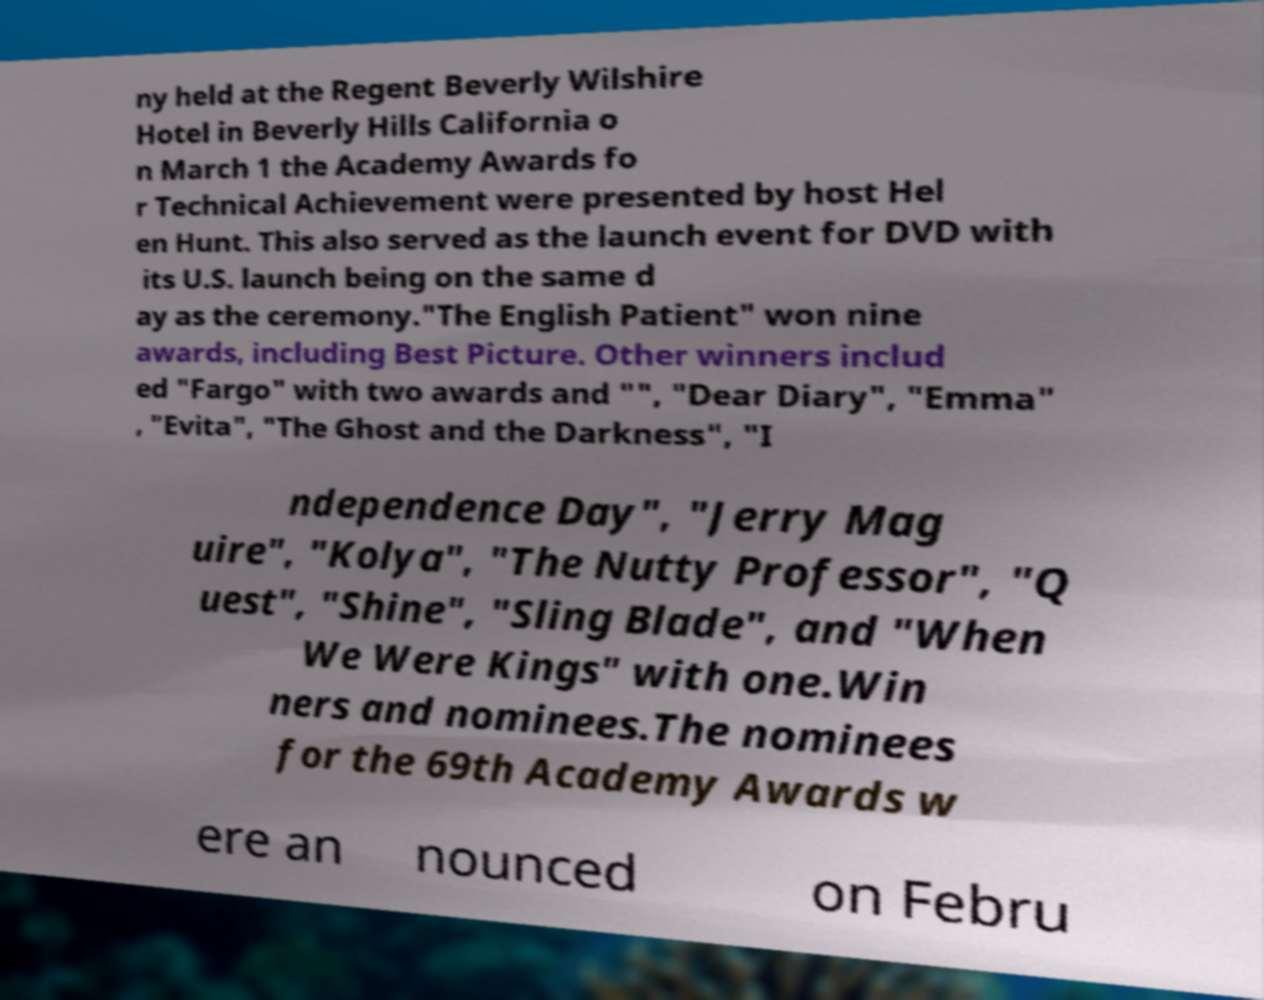Could you assist in decoding the text presented in this image and type it out clearly? ny held at the Regent Beverly Wilshire Hotel in Beverly Hills California o n March 1 the Academy Awards fo r Technical Achievement were presented by host Hel en Hunt. This also served as the launch event for DVD with its U.S. launch being on the same d ay as the ceremony."The English Patient" won nine awards, including Best Picture. Other winners includ ed "Fargo" with two awards and "", "Dear Diary", "Emma" , "Evita", "The Ghost and the Darkness", "I ndependence Day", "Jerry Mag uire", "Kolya", "The Nutty Professor", "Q uest", "Shine", "Sling Blade", and "When We Were Kings" with one.Win ners and nominees.The nominees for the 69th Academy Awards w ere an nounced on Febru 